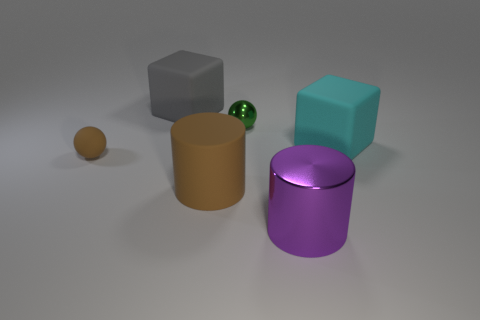What is the material of the object that is the same size as the brown rubber ball?
Your answer should be very brief. Metal. Is there another matte object of the same shape as the big gray thing?
Provide a succinct answer. Yes. There is a object in front of the brown rubber cylinder; what is its shape?
Your answer should be very brief. Cylinder. What number of purple metal things are there?
Offer a very short reply. 1. What color is the sphere that is made of the same material as the big brown thing?
Give a very brief answer. Brown. How many small objects are either green things or gray rubber objects?
Ensure brevity in your answer.  1. What number of cyan matte cubes are to the left of the big cyan matte thing?
Provide a short and direct response. 0. What color is the other small object that is the same shape as the green thing?
Offer a terse response. Brown. How many matte objects are large cyan things or gray cubes?
Provide a short and direct response. 2. There is a matte cube that is behind the big matte block in front of the gray cube; are there any green balls in front of it?
Your response must be concise. Yes. 